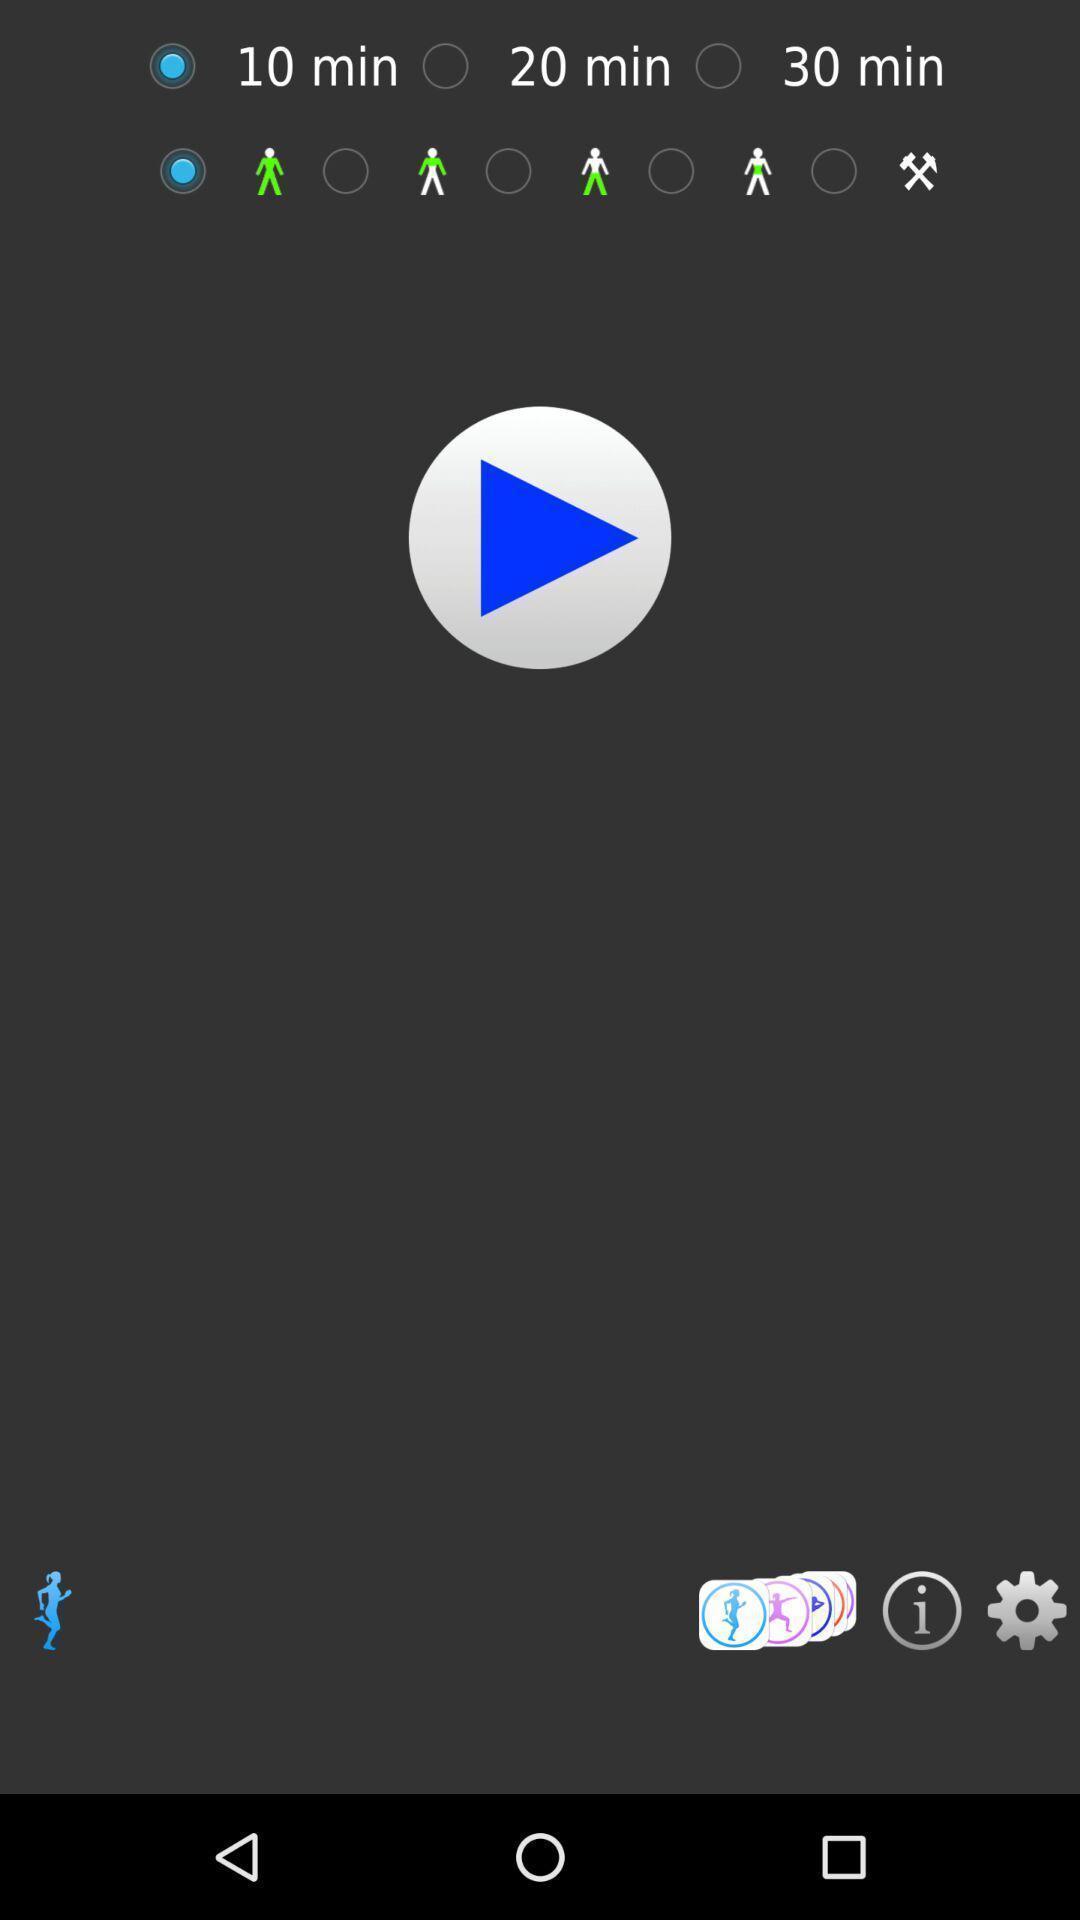Tell me about the visual elements in this screen capture. Page showing multiple options on app. 